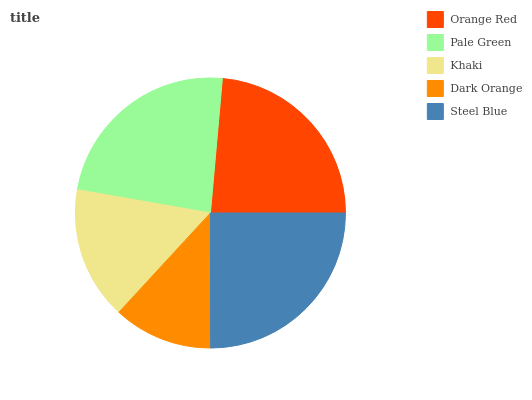Is Dark Orange the minimum?
Answer yes or no. Yes. Is Steel Blue the maximum?
Answer yes or no. Yes. Is Pale Green the minimum?
Answer yes or no. No. Is Pale Green the maximum?
Answer yes or no. No. Is Pale Green greater than Orange Red?
Answer yes or no. Yes. Is Orange Red less than Pale Green?
Answer yes or no. Yes. Is Orange Red greater than Pale Green?
Answer yes or no. No. Is Pale Green less than Orange Red?
Answer yes or no. No. Is Orange Red the high median?
Answer yes or no. Yes. Is Orange Red the low median?
Answer yes or no. Yes. Is Pale Green the high median?
Answer yes or no. No. Is Steel Blue the low median?
Answer yes or no. No. 